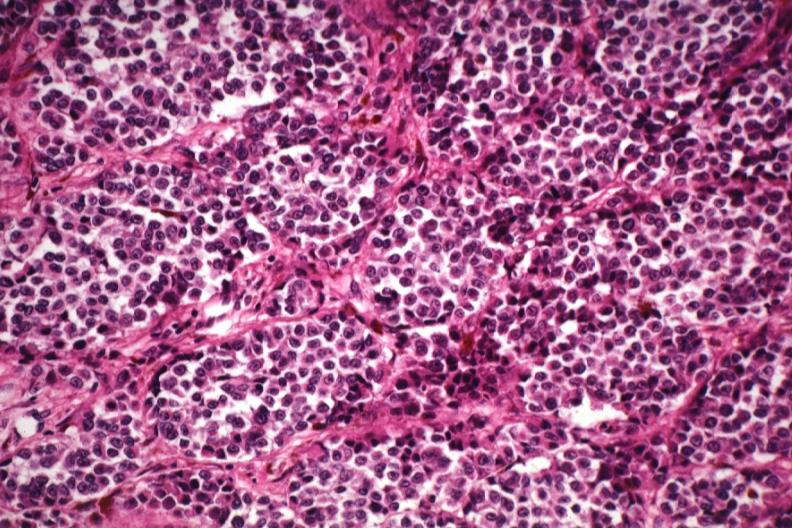s malignant melanoma present?
Answer the question using a single word or phrase. Yes 